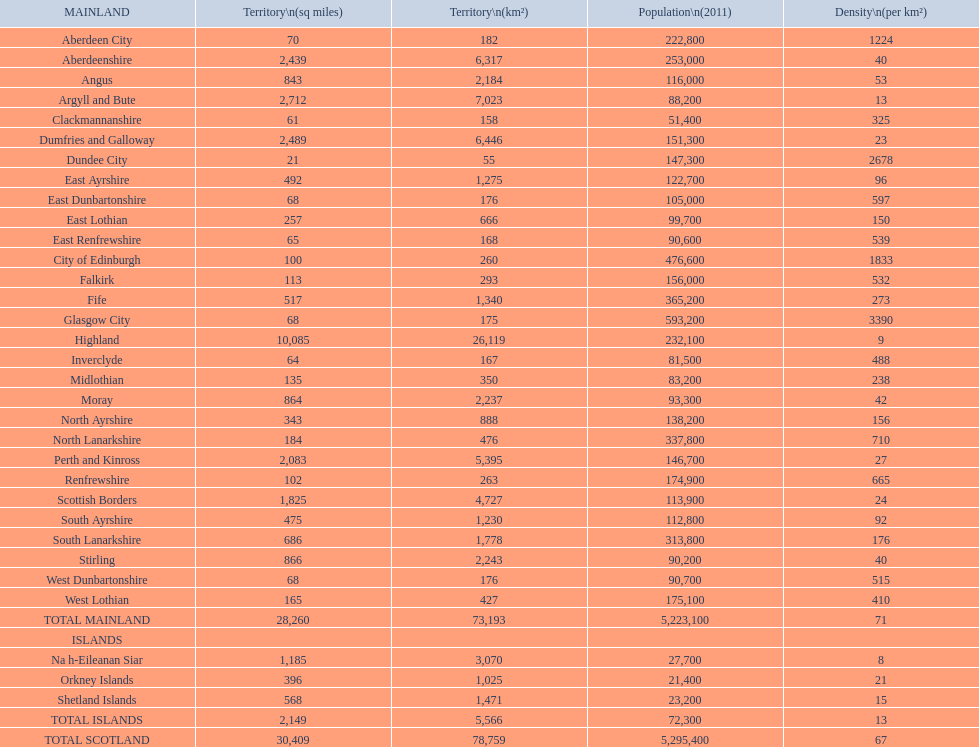What is the total area of east lothian, angus, and dundee city? 1121. 